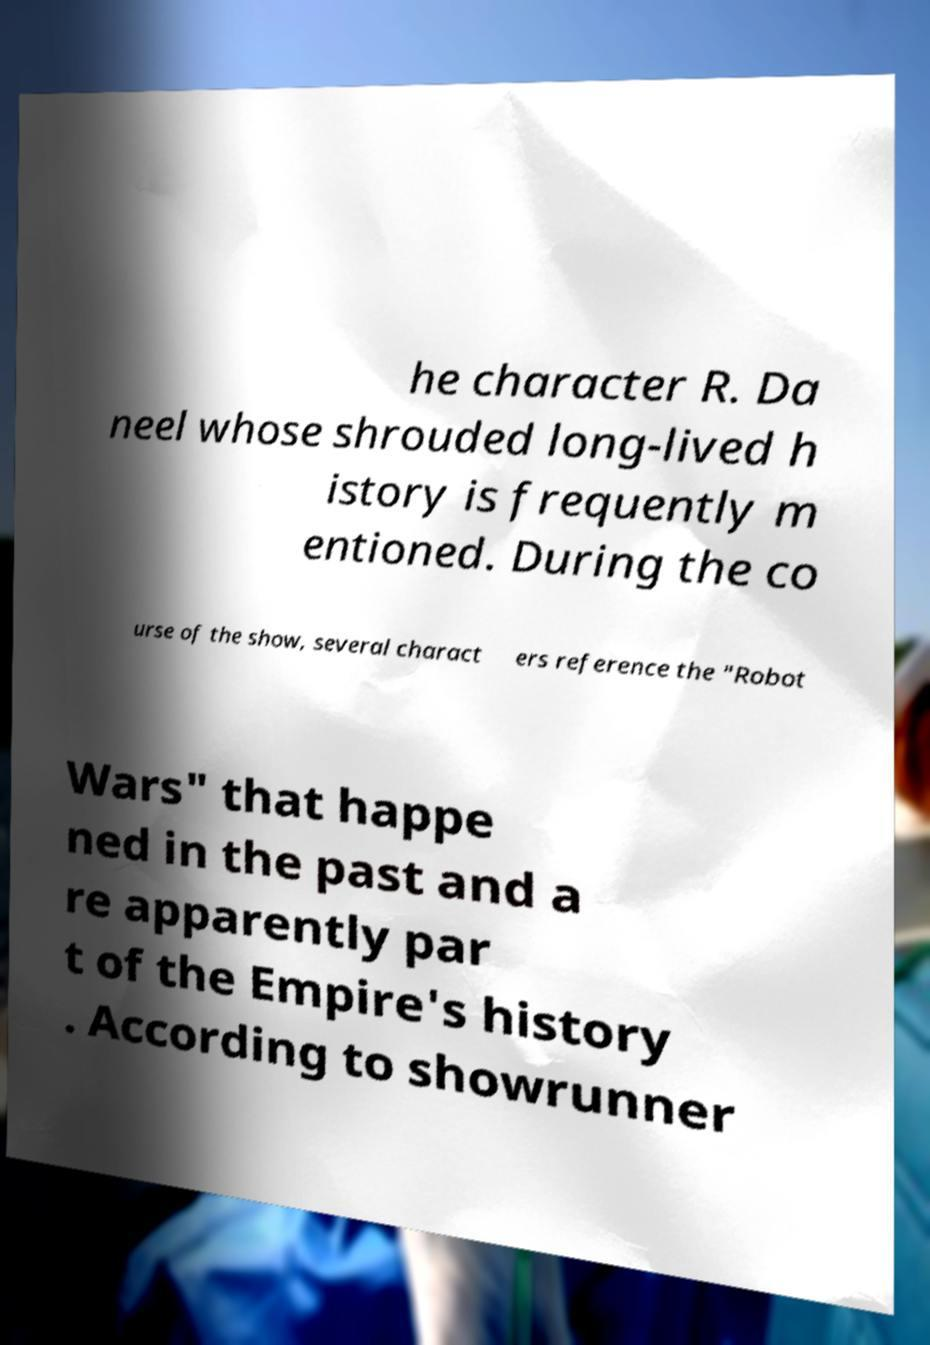For documentation purposes, I need the text within this image transcribed. Could you provide that? he character R. Da neel whose shrouded long-lived h istory is frequently m entioned. During the co urse of the show, several charact ers reference the "Robot Wars" that happe ned in the past and a re apparently par t of the Empire's history . According to showrunner 